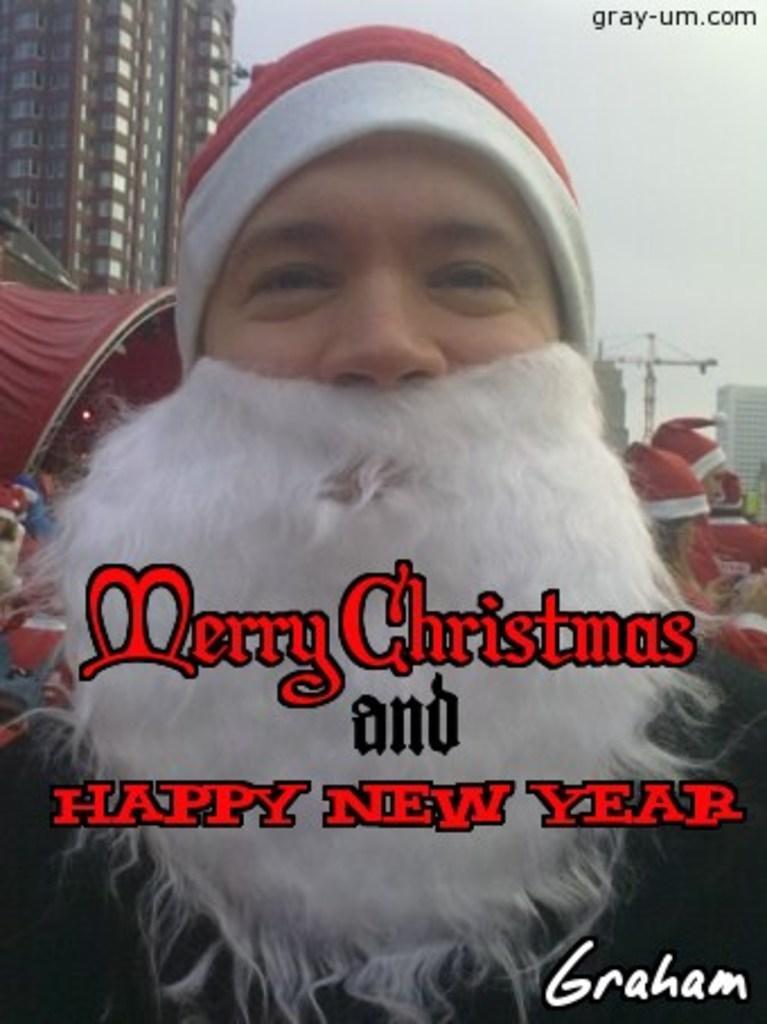In one or two sentences, can you explain what this image depicts? In this image we can see a person in Santa get up. In the background there are few persons wore caps on their heads, buildings, windows, crane, poles, light and other objects. 